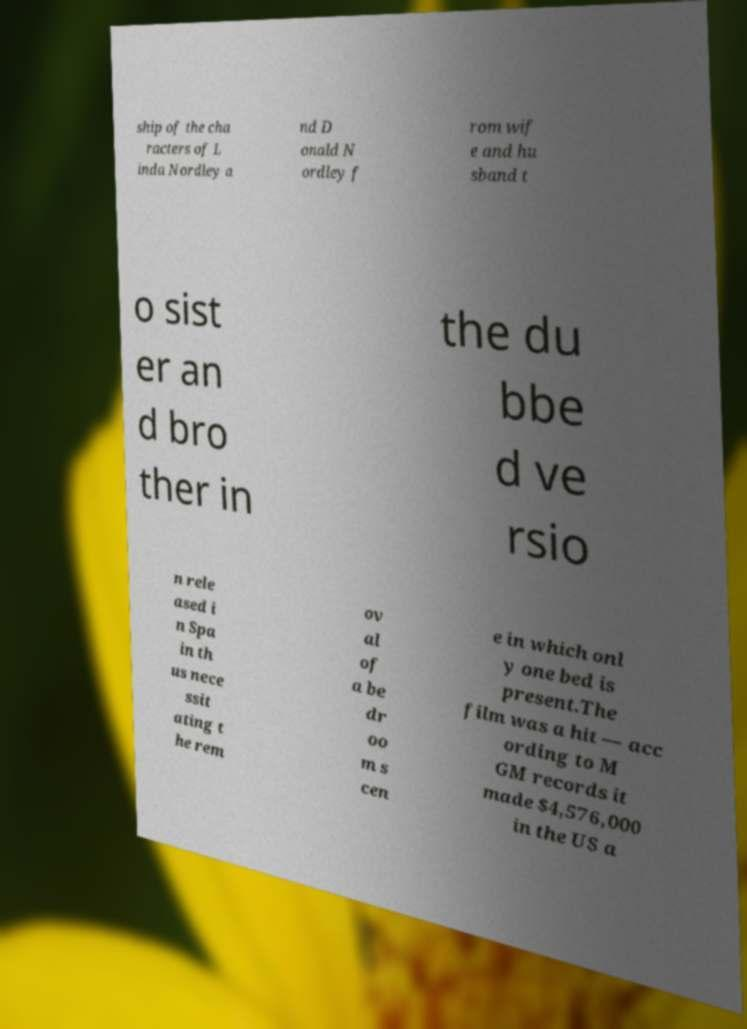What messages or text are displayed in this image? I need them in a readable, typed format. ship of the cha racters of L inda Nordley a nd D onald N ordley f rom wif e and hu sband t o sist er an d bro ther in the du bbe d ve rsio n rele ased i n Spa in th us nece ssit ating t he rem ov al of a be dr oo m s cen e in which onl y one bed is present.The film was a hit — acc ording to M GM records it made $4,576,000 in the US a 